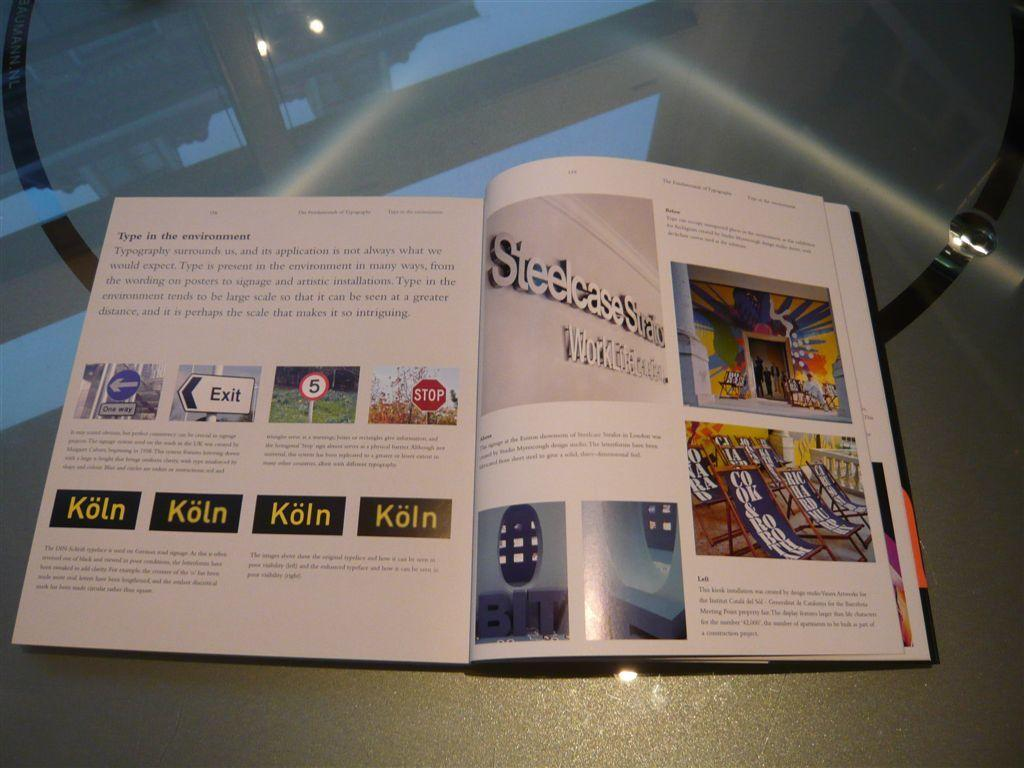<image>
Provide a brief description of the given image. A book is open to a page showing an exit and a stop sign. 